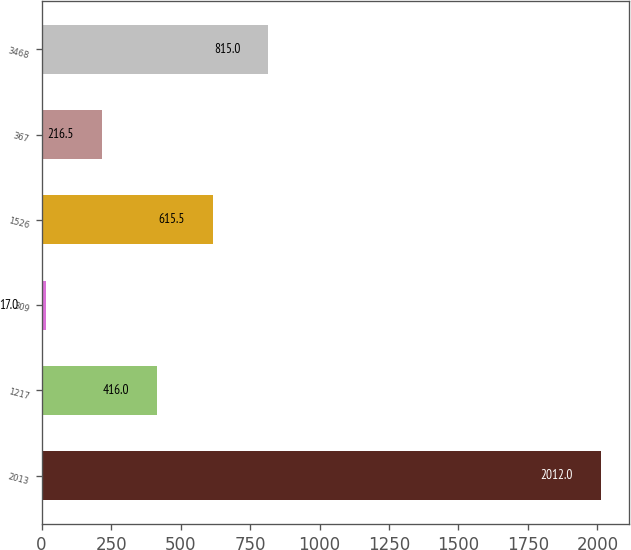<chart> <loc_0><loc_0><loc_500><loc_500><bar_chart><fcel>2013<fcel>1217<fcel>309<fcel>1526<fcel>367<fcel>3468<nl><fcel>2012<fcel>416<fcel>17<fcel>615.5<fcel>216.5<fcel>815<nl></chart> 